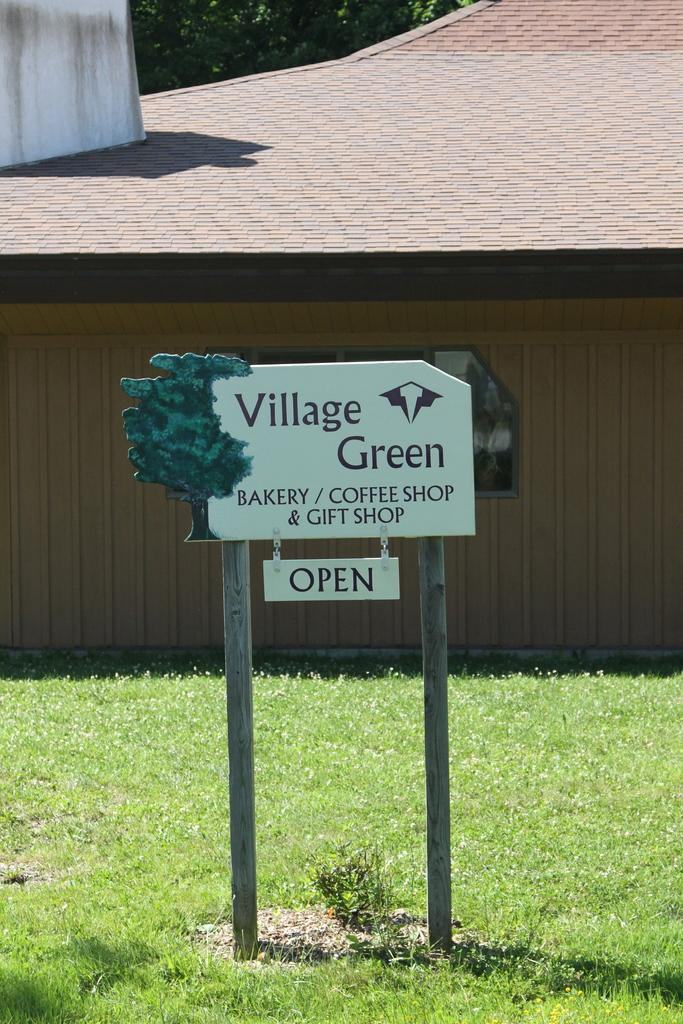What is the main object in the center of the image? There is a sign board in the center of the image. What does the sign board say? The sign board has the text "Village Green" on it. What can be seen in the background of the image? There are trees, grass, a building, a roof, and a wall in the background of the image. How many clams are visible on the roof in the image? There are no clams visible in the image, and the roof is not mentioned as having any clams. What type of prison can be seen in the background of the image? There is no prison present in the image; it features a sign board, trees, grass, a building, a roof, and a wall in the background. 